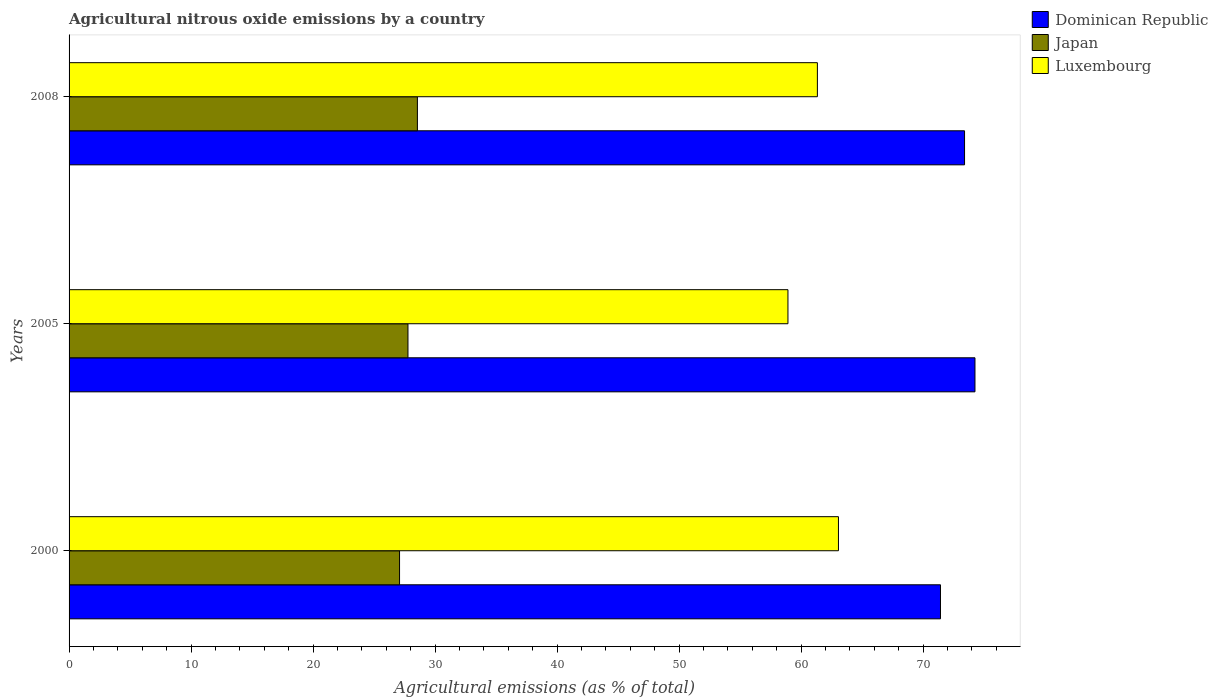Are the number of bars on each tick of the Y-axis equal?
Provide a succinct answer. Yes. How many bars are there on the 1st tick from the bottom?
Make the answer very short. 3. What is the label of the 2nd group of bars from the top?
Your answer should be very brief. 2005. In how many cases, is the number of bars for a given year not equal to the number of legend labels?
Give a very brief answer. 0. What is the amount of agricultural nitrous oxide emitted in Japan in 2000?
Keep it short and to the point. 27.09. Across all years, what is the maximum amount of agricultural nitrous oxide emitted in Luxembourg?
Give a very brief answer. 63.06. Across all years, what is the minimum amount of agricultural nitrous oxide emitted in Dominican Republic?
Provide a short and direct response. 71.43. What is the total amount of agricultural nitrous oxide emitted in Japan in the graph?
Provide a succinct answer. 83.42. What is the difference between the amount of agricultural nitrous oxide emitted in Dominican Republic in 2000 and that in 2008?
Your answer should be very brief. -1.97. What is the difference between the amount of agricultural nitrous oxide emitted in Dominican Republic in 2005 and the amount of agricultural nitrous oxide emitted in Japan in 2000?
Ensure brevity in your answer.  47.16. What is the average amount of agricultural nitrous oxide emitted in Japan per year?
Your answer should be very brief. 27.81. In the year 2000, what is the difference between the amount of agricultural nitrous oxide emitted in Japan and amount of agricultural nitrous oxide emitted in Dominican Republic?
Ensure brevity in your answer.  -44.34. In how many years, is the amount of agricultural nitrous oxide emitted in Luxembourg greater than 42 %?
Your answer should be very brief. 3. What is the ratio of the amount of agricultural nitrous oxide emitted in Japan in 2005 to that in 2008?
Your response must be concise. 0.97. Is the amount of agricultural nitrous oxide emitted in Luxembourg in 2005 less than that in 2008?
Make the answer very short. Yes. Is the difference between the amount of agricultural nitrous oxide emitted in Japan in 2000 and 2005 greater than the difference between the amount of agricultural nitrous oxide emitted in Dominican Republic in 2000 and 2005?
Provide a succinct answer. Yes. What is the difference between the highest and the second highest amount of agricultural nitrous oxide emitted in Japan?
Ensure brevity in your answer.  0.77. What is the difference between the highest and the lowest amount of agricultural nitrous oxide emitted in Japan?
Provide a succinct answer. 1.46. How many bars are there?
Provide a short and direct response. 9. What is the difference between two consecutive major ticks on the X-axis?
Give a very brief answer. 10. Are the values on the major ticks of X-axis written in scientific E-notation?
Provide a succinct answer. No. Does the graph contain grids?
Offer a terse response. No. How many legend labels are there?
Ensure brevity in your answer.  3. How are the legend labels stacked?
Your answer should be compact. Vertical. What is the title of the graph?
Provide a succinct answer. Agricultural nitrous oxide emissions by a country. What is the label or title of the X-axis?
Offer a terse response. Agricultural emissions (as % of total). What is the label or title of the Y-axis?
Keep it short and to the point. Years. What is the Agricultural emissions (as % of total) in Dominican Republic in 2000?
Keep it short and to the point. 71.43. What is the Agricultural emissions (as % of total) of Japan in 2000?
Offer a terse response. 27.09. What is the Agricultural emissions (as % of total) of Luxembourg in 2000?
Keep it short and to the point. 63.06. What is the Agricultural emissions (as % of total) of Dominican Republic in 2005?
Offer a terse response. 74.25. What is the Agricultural emissions (as % of total) of Japan in 2005?
Make the answer very short. 27.78. What is the Agricultural emissions (as % of total) in Luxembourg in 2005?
Give a very brief answer. 58.93. What is the Agricultural emissions (as % of total) in Dominican Republic in 2008?
Ensure brevity in your answer.  73.4. What is the Agricultural emissions (as % of total) of Japan in 2008?
Your answer should be compact. 28.55. What is the Agricultural emissions (as % of total) of Luxembourg in 2008?
Make the answer very short. 61.34. Across all years, what is the maximum Agricultural emissions (as % of total) in Dominican Republic?
Your response must be concise. 74.25. Across all years, what is the maximum Agricultural emissions (as % of total) in Japan?
Ensure brevity in your answer.  28.55. Across all years, what is the maximum Agricultural emissions (as % of total) in Luxembourg?
Your response must be concise. 63.06. Across all years, what is the minimum Agricultural emissions (as % of total) in Dominican Republic?
Provide a short and direct response. 71.43. Across all years, what is the minimum Agricultural emissions (as % of total) in Japan?
Your response must be concise. 27.09. Across all years, what is the minimum Agricultural emissions (as % of total) in Luxembourg?
Make the answer very short. 58.93. What is the total Agricultural emissions (as % of total) in Dominican Republic in the graph?
Provide a succinct answer. 219.08. What is the total Agricultural emissions (as % of total) of Japan in the graph?
Provide a short and direct response. 83.42. What is the total Agricultural emissions (as % of total) of Luxembourg in the graph?
Give a very brief answer. 183.33. What is the difference between the Agricultural emissions (as % of total) of Dominican Republic in 2000 and that in 2005?
Offer a very short reply. -2.83. What is the difference between the Agricultural emissions (as % of total) of Japan in 2000 and that in 2005?
Your answer should be compact. -0.69. What is the difference between the Agricultural emissions (as % of total) in Luxembourg in 2000 and that in 2005?
Provide a short and direct response. 4.14. What is the difference between the Agricultural emissions (as % of total) of Dominican Republic in 2000 and that in 2008?
Offer a terse response. -1.97. What is the difference between the Agricultural emissions (as % of total) of Japan in 2000 and that in 2008?
Provide a short and direct response. -1.46. What is the difference between the Agricultural emissions (as % of total) of Luxembourg in 2000 and that in 2008?
Make the answer very short. 1.73. What is the difference between the Agricultural emissions (as % of total) of Dominican Republic in 2005 and that in 2008?
Your answer should be compact. 0.85. What is the difference between the Agricultural emissions (as % of total) of Japan in 2005 and that in 2008?
Make the answer very short. -0.77. What is the difference between the Agricultural emissions (as % of total) of Luxembourg in 2005 and that in 2008?
Your answer should be very brief. -2.41. What is the difference between the Agricultural emissions (as % of total) of Dominican Republic in 2000 and the Agricultural emissions (as % of total) of Japan in 2005?
Your answer should be compact. 43.65. What is the difference between the Agricultural emissions (as % of total) in Dominican Republic in 2000 and the Agricultural emissions (as % of total) in Luxembourg in 2005?
Offer a very short reply. 12.5. What is the difference between the Agricultural emissions (as % of total) in Japan in 2000 and the Agricultural emissions (as % of total) in Luxembourg in 2005?
Ensure brevity in your answer.  -31.84. What is the difference between the Agricultural emissions (as % of total) in Dominican Republic in 2000 and the Agricultural emissions (as % of total) in Japan in 2008?
Make the answer very short. 42.88. What is the difference between the Agricultural emissions (as % of total) of Dominican Republic in 2000 and the Agricultural emissions (as % of total) of Luxembourg in 2008?
Give a very brief answer. 10.09. What is the difference between the Agricultural emissions (as % of total) in Japan in 2000 and the Agricultural emissions (as % of total) in Luxembourg in 2008?
Give a very brief answer. -34.25. What is the difference between the Agricultural emissions (as % of total) in Dominican Republic in 2005 and the Agricultural emissions (as % of total) in Japan in 2008?
Give a very brief answer. 45.7. What is the difference between the Agricultural emissions (as % of total) of Dominican Republic in 2005 and the Agricultural emissions (as % of total) of Luxembourg in 2008?
Offer a very short reply. 12.92. What is the difference between the Agricultural emissions (as % of total) in Japan in 2005 and the Agricultural emissions (as % of total) in Luxembourg in 2008?
Make the answer very short. -33.56. What is the average Agricultural emissions (as % of total) of Dominican Republic per year?
Offer a terse response. 73.03. What is the average Agricultural emissions (as % of total) in Japan per year?
Offer a terse response. 27.81. What is the average Agricultural emissions (as % of total) of Luxembourg per year?
Your answer should be very brief. 61.11. In the year 2000, what is the difference between the Agricultural emissions (as % of total) in Dominican Republic and Agricultural emissions (as % of total) in Japan?
Give a very brief answer. 44.34. In the year 2000, what is the difference between the Agricultural emissions (as % of total) in Dominican Republic and Agricultural emissions (as % of total) in Luxembourg?
Give a very brief answer. 8.36. In the year 2000, what is the difference between the Agricultural emissions (as % of total) in Japan and Agricultural emissions (as % of total) in Luxembourg?
Offer a very short reply. -35.98. In the year 2005, what is the difference between the Agricultural emissions (as % of total) in Dominican Republic and Agricultural emissions (as % of total) in Japan?
Give a very brief answer. 46.48. In the year 2005, what is the difference between the Agricultural emissions (as % of total) in Dominican Republic and Agricultural emissions (as % of total) in Luxembourg?
Provide a succinct answer. 15.33. In the year 2005, what is the difference between the Agricultural emissions (as % of total) of Japan and Agricultural emissions (as % of total) of Luxembourg?
Your answer should be very brief. -31.15. In the year 2008, what is the difference between the Agricultural emissions (as % of total) in Dominican Republic and Agricultural emissions (as % of total) in Japan?
Offer a very short reply. 44.85. In the year 2008, what is the difference between the Agricultural emissions (as % of total) of Dominican Republic and Agricultural emissions (as % of total) of Luxembourg?
Ensure brevity in your answer.  12.06. In the year 2008, what is the difference between the Agricultural emissions (as % of total) of Japan and Agricultural emissions (as % of total) of Luxembourg?
Ensure brevity in your answer.  -32.79. What is the ratio of the Agricultural emissions (as % of total) of Dominican Republic in 2000 to that in 2005?
Give a very brief answer. 0.96. What is the ratio of the Agricultural emissions (as % of total) of Japan in 2000 to that in 2005?
Offer a very short reply. 0.98. What is the ratio of the Agricultural emissions (as % of total) of Luxembourg in 2000 to that in 2005?
Your response must be concise. 1.07. What is the ratio of the Agricultural emissions (as % of total) of Dominican Republic in 2000 to that in 2008?
Make the answer very short. 0.97. What is the ratio of the Agricultural emissions (as % of total) of Japan in 2000 to that in 2008?
Provide a succinct answer. 0.95. What is the ratio of the Agricultural emissions (as % of total) in Luxembourg in 2000 to that in 2008?
Offer a very short reply. 1.03. What is the ratio of the Agricultural emissions (as % of total) in Dominican Republic in 2005 to that in 2008?
Provide a succinct answer. 1.01. What is the ratio of the Agricultural emissions (as % of total) in Japan in 2005 to that in 2008?
Your answer should be compact. 0.97. What is the ratio of the Agricultural emissions (as % of total) of Luxembourg in 2005 to that in 2008?
Provide a short and direct response. 0.96. What is the difference between the highest and the second highest Agricultural emissions (as % of total) in Dominican Republic?
Provide a short and direct response. 0.85. What is the difference between the highest and the second highest Agricultural emissions (as % of total) of Japan?
Offer a terse response. 0.77. What is the difference between the highest and the second highest Agricultural emissions (as % of total) in Luxembourg?
Keep it short and to the point. 1.73. What is the difference between the highest and the lowest Agricultural emissions (as % of total) of Dominican Republic?
Ensure brevity in your answer.  2.83. What is the difference between the highest and the lowest Agricultural emissions (as % of total) of Japan?
Ensure brevity in your answer.  1.46. What is the difference between the highest and the lowest Agricultural emissions (as % of total) in Luxembourg?
Ensure brevity in your answer.  4.14. 